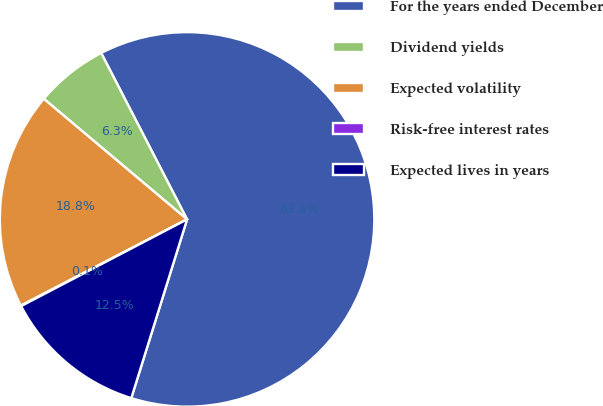Convert chart to OTSL. <chart><loc_0><loc_0><loc_500><loc_500><pie_chart><fcel>For the years ended December<fcel>Dividend yields<fcel>Expected volatility<fcel>Risk-free interest rates<fcel>Expected lives in years<nl><fcel>62.4%<fcel>6.28%<fcel>18.75%<fcel>0.05%<fcel>12.52%<nl></chart> 